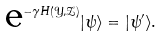Convert formula to latex. <formula><loc_0><loc_0><loc_500><loc_500>\text {e} ^ { - \gamma H ( \mathcal { Y } , \mathcal { Z } ) } | \psi \rangle = | \psi ^ { \prime } \rangle .</formula> 